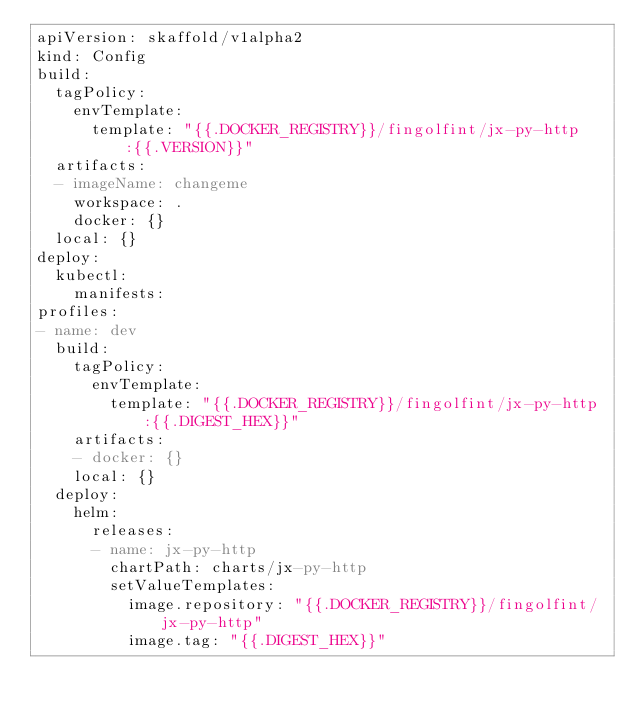Convert code to text. <code><loc_0><loc_0><loc_500><loc_500><_YAML_>apiVersion: skaffold/v1alpha2
kind: Config
build:
  tagPolicy:
    envTemplate:
      template: "{{.DOCKER_REGISTRY}}/fingolfint/jx-py-http:{{.VERSION}}"
  artifacts:
  - imageName: changeme
    workspace: .
    docker: {}
  local: {}
deploy:
  kubectl:
    manifests:
profiles:
- name: dev
  build:
    tagPolicy:
      envTemplate:
        template: "{{.DOCKER_REGISTRY}}/fingolfint/jx-py-http:{{.DIGEST_HEX}}"
    artifacts:
    - docker: {}
    local: {}
  deploy:
    helm:
      releases:
      - name: jx-py-http
        chartPath: charts/jx-py-http
        setValueTemplates:
          image.repository: "{{.DOCKER_REGISTRY}}/fingolfint/jx-py-http"
          image.tag: "{{.DIGEST_HEX}}"
</code> 